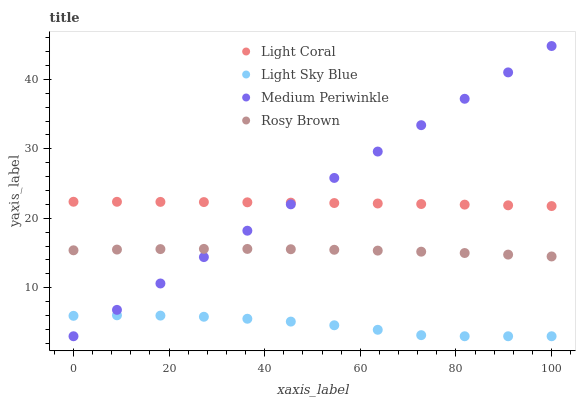Does Light Sky Blue have the minimum area under the curve?
Answer yes or no. Yes. Does Medium Periwinkle have the maximum area under the curve?
Answer yes or no. Yes. Does Rosy Brown have the minimum area under the curve?
Answer yes or no. No. Does Rosy Brown have the maximum area under the curve?
Answer yes or no. No. Is Medium Periwinkle the smoothest?
Answer yes or no. Yes. Is Light Sky Blue the roughest?
Answer yes or no. Yes. Is Rosy Brown the smoothest?
Answer yes or no. No. Is Rosy Brown the roughest?
Answer yes or no. No. Does Light Sky Blue have the lowest value?
Answer yes or no. Yes. Does Rosy Brown have the lowest value?
Answer yes or no. No. Does Medium Periwinkle have the highest value?
Answer yes or no. Yes. Does Rosy Brown have the highest value?
Answer yes or no. No. Is Rosy Brown less than Light Coral?
Answer yes or no. Yes. Is Light Coral greater than Light Sky Blue?
Answer yes or no. Yes. Does Medium Periwinkle intersect Rosy Brown?
Answer yes or no. Yes. Is Medium Periwinkle less than Rosy Brown?
Answer yes or no. No. Is Medium Periwinkle greater than Rosy Brown?
Answer yes or no. No. Does Rosy Brown intersect Light Coral?
Answer yes or no. No. 